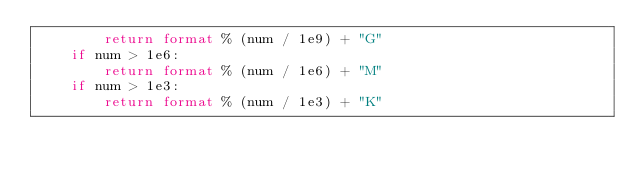Convert code to text. <code><loc_0><loc_0><loc_500><loc_500><_Python_>        return format % (num / 1e9) + "G"
    if num > 1e6:
        return format % (num / 1e6) + "M"
    if num > 1e3:
        return format % (num / 1e3) + "K"
</code> 